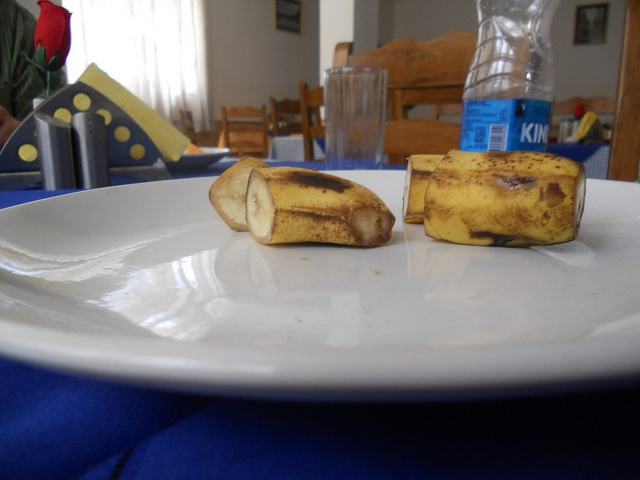Describe the objects in this image and their specific colors. I can see dining table in black, darkgray, lightgray, olive, and gray tones, banana in black, olive, tan, and maroon tones, bottle in black, gray, darkgray, blue, and navy tones, chair in black, maroon, and gray tones, and cup in black, gray, brown, darkblue, and blue tones in this image. 